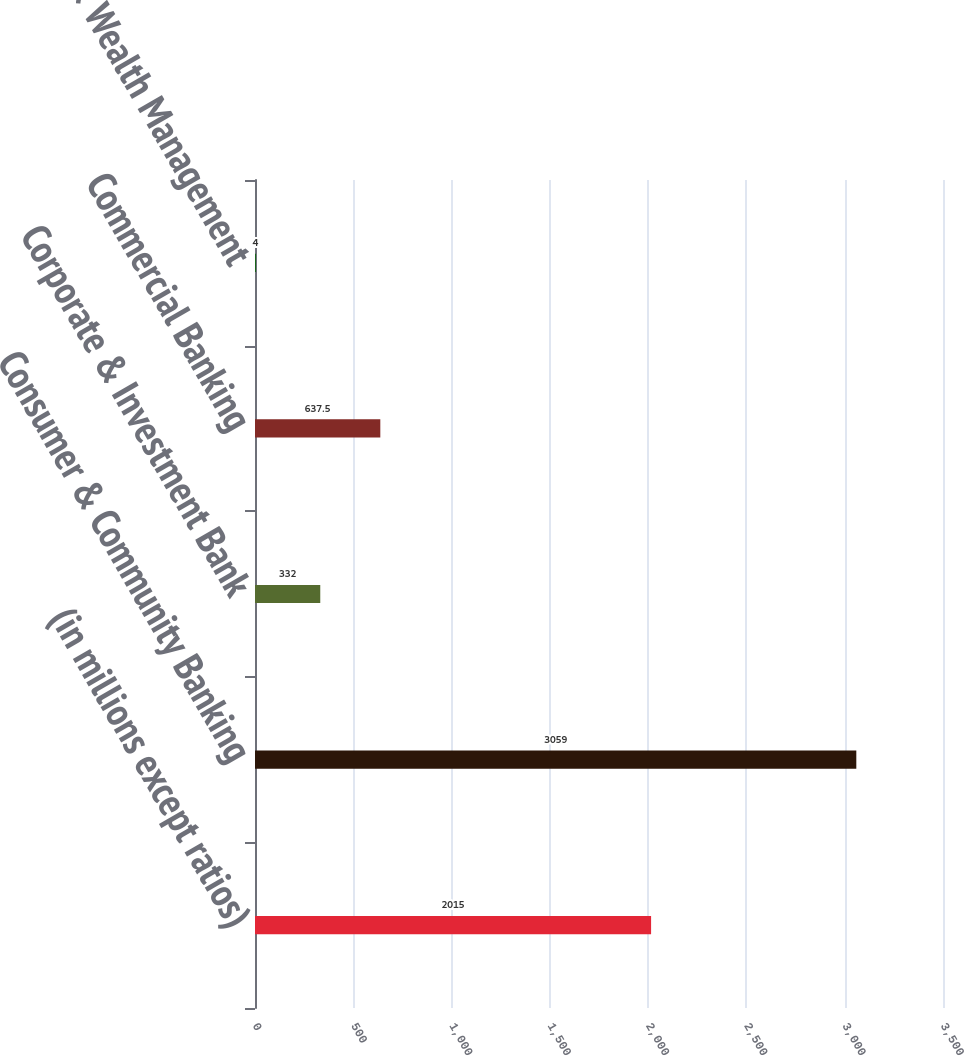Convert chart to OTSL. <chart><loc_0><loc_0><loc_500><loc_500><bar_chart><fcel>(in millions except ratios)<fcel>Consumer & Community Banking<fcel>Corporate & Investment Bank<fcel>Commercial Banking<fcel>Asset & Wealth Management<nl><fcel>2015<fcel>3059<fcel>332<fcel>637.5<fcel>4<nl></chart> 